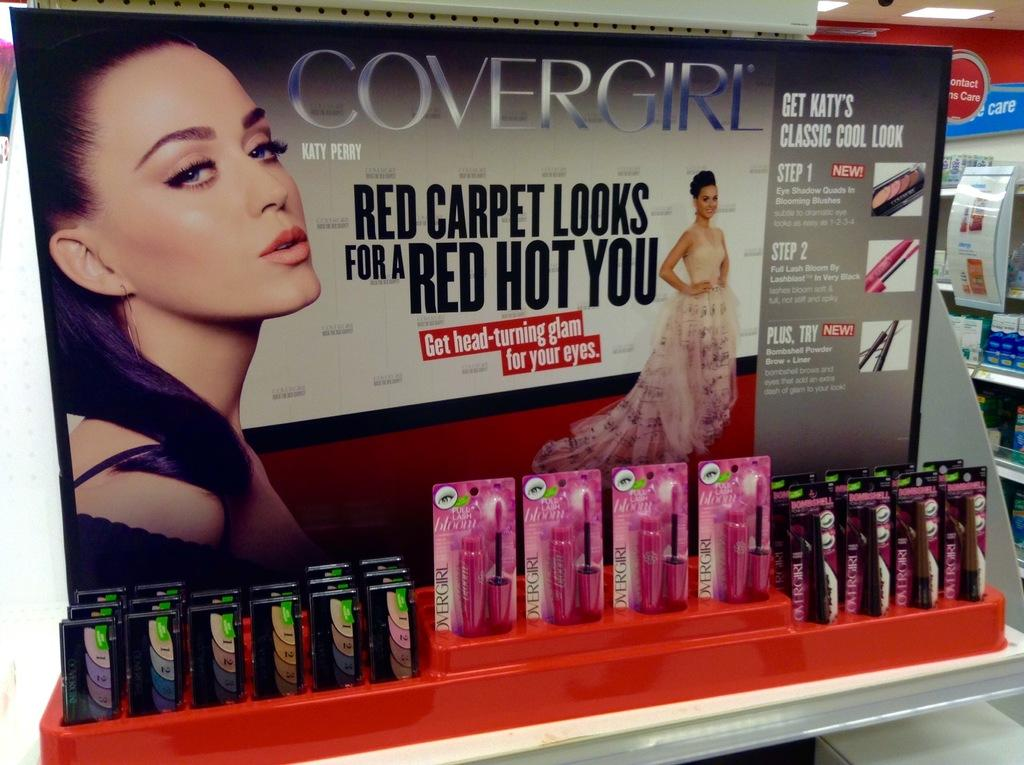What type of items can be seen in the image? There are cosmetics in the image. What else is present in the image besides cosmetics? There is a board in the image, and there are two persons present. What is written on the board? There is writing on the board. What can be seen in the background of the image? There are objects and lights in the background of the image. How does the chin of the person on the left increase in size in the image? There is no indication in the image that the chin of the person on the left is increasing in size. 